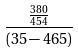Convert formula to latex. <formula><loc_0><loc_0><loc_500><loc_500>\frac { \frac { 3 8 0 } { 4 5 4 } } { ( 3 5 - 4 6 5 ) }</formula> 